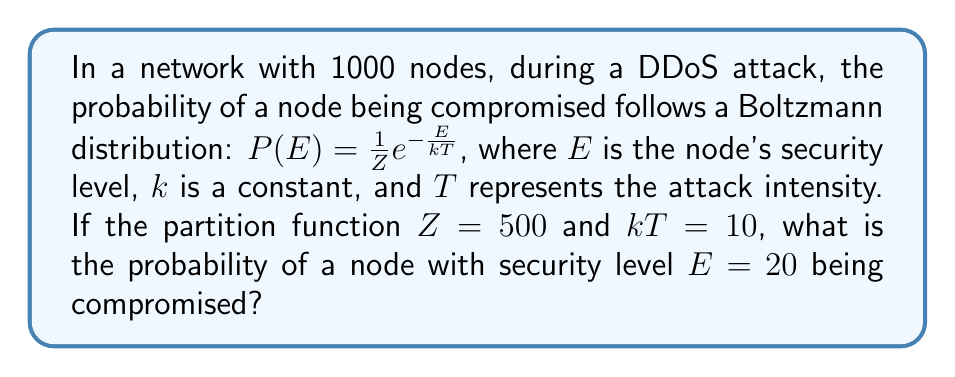What is the answer to this math problem? To solve this problem, we'll follow these steps:

1) We are given the Boltzmann distribution formula:

   $$P(E) = \frac{1}{Z}e^{-\frac{E}{kT}}$$

2) We know the following values:
   - $Z = 500$ (partition function)
   - $kT = 10$ (product of constant $k$ and attack intensity $T$)
   - $E = 20$ (security level of the node we're interested in)

3) Let's substitute these values into the formula:

   $$P(20) = \frac{1}{500}e^{-\frac{20}{10}}$$

4) Simplify the exponent:

   $$P(20) = \frac{1}{500}e^{-2}$$

5) Calculate $e^{-2}$:

   $$P(20) = \frac{1}{500} \cdot 0.1353$$

6) Multiply:

   $$P(20) = 0.0002706$$

This represents the probability of a node with security level 20 being compromised during the DDoS attack under the given conditions.
Answer: 0.0002706 